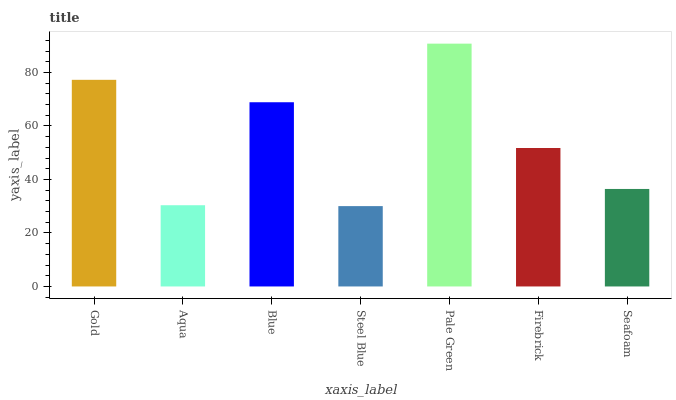Is Steel Blue the minimum?
Answer yes or no. Yes. Is Pale Green the maximum?
Answer yes or no. Yes. Is Aqua the minimum?
Answer yes or no. No. Is Aqua the maximum?
Answer yes or no. No. Is Gold greater than Aqua?
Answer yes or no. Yes. Is Aqua less than Gold?
Answer yes or no. Yes. Is Aqua greater than Gold?
Answer yes or no. No. Is Gold less than Aqua?
Answer yes or no. No. Is Firebrick the high median?
Answer yes or no. Yes. Is Firebrick the low median?
Answer yes or no. Yes. Is Steel Blue the high median?
Answer yes or no. No. Is Aqua the low median?
Answer yes or no. No. 